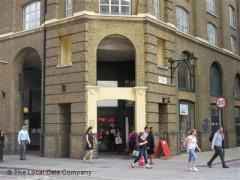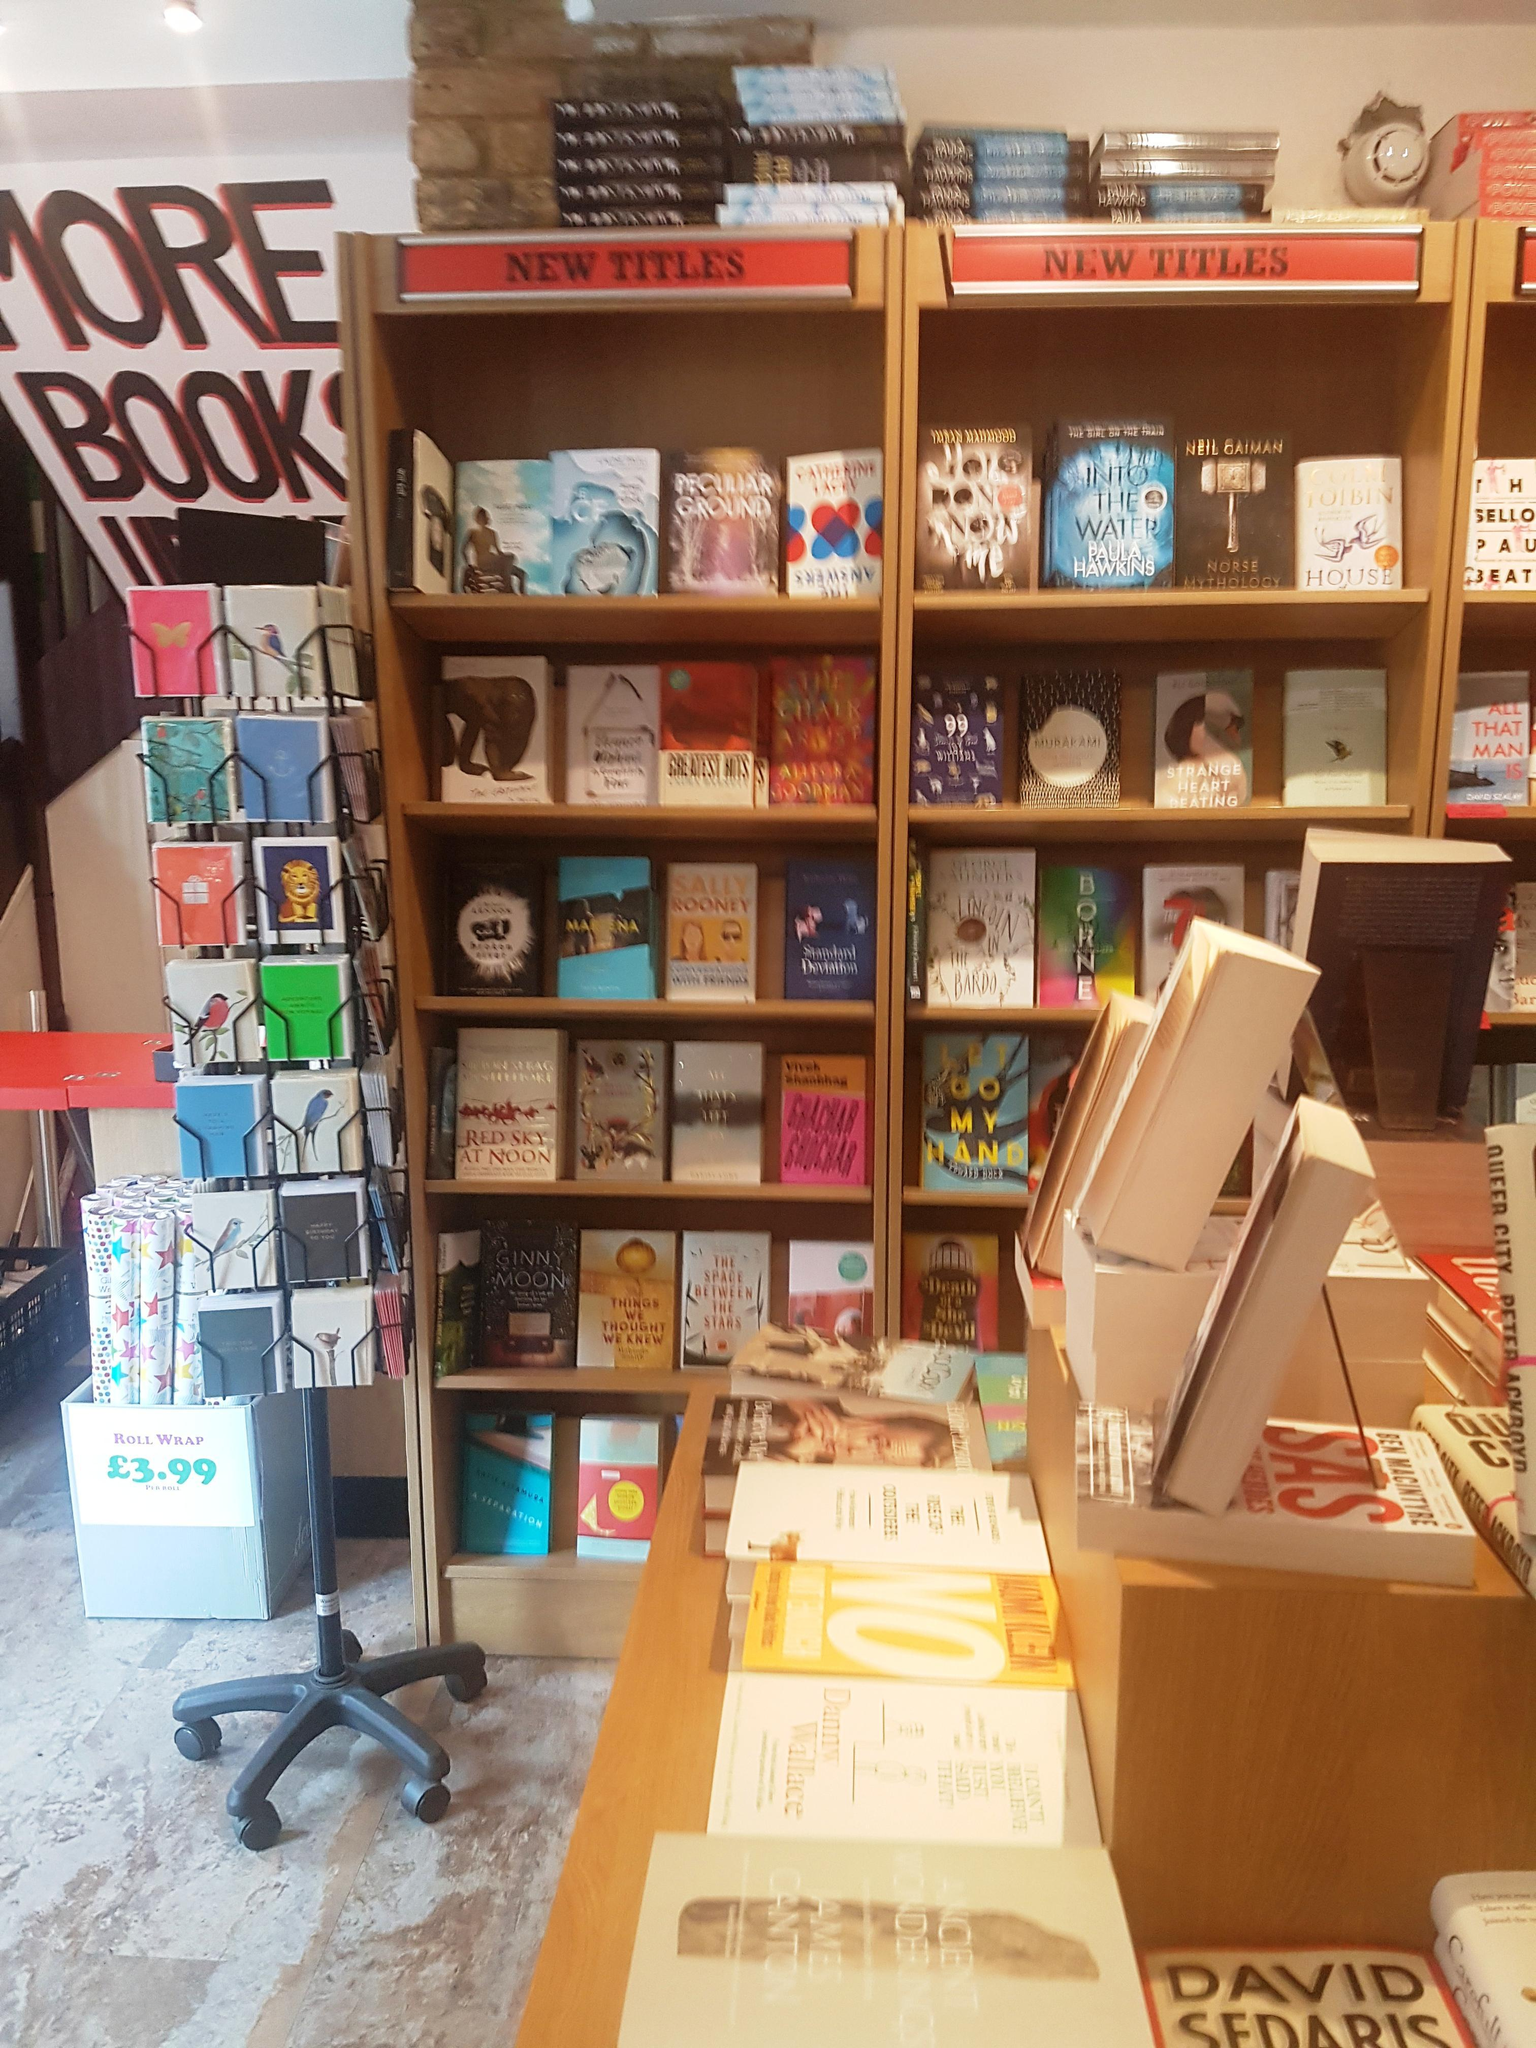The first image is the image on the left, the second image is the image on the right. Examine the images to the left and right. Is the description "A large arch shape is in the center of the left image, surrounded by other window shapes." accurate? Answer yes or no. Yes. The first image is the image on the left, the second image is the image on the right. Assess this claim about the two images: "There are people visible, walking right outside of the building.". Correct or not? Answer yes or no. Yes. 